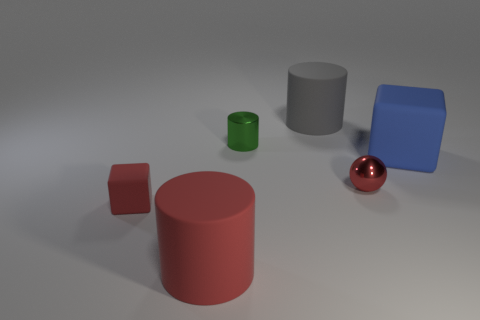There is a tiny block that is the same color as the tiny metallic ball; what is its material?
Offer a terse response. Rubber. How many things are small objects on the left side of the red cylinder or large things?
Offer a very short reply. 4. There is a large cylinder right of the big red rubber object; how many big matte cylinders are left of it?
Offer a terse response. 1. Is the number of big gray objects that are right of the big blue matte block less than the number of small metallic objects that are behind the red shiny thing?
Give a very brief answer. Yes. There is a tiny shiny thing that is in front of the matte cube that is to the right of the big gray object; what shape is it?
Keep it short and to the point. Sphere. What number of other things are the same material as the blue cube?
Provide a short and direct response. 3. Are there more tiny red things than rubber objects?
Your answer should be compact. No. There is a red object behind the rubber block to the left of the matte cylinder that is in front of the small red matte block; what size is it?
Provide a short and direct response. Small. There is a red rubber cube; is it the same size as the metallic thing on the left side of the gray cylinder?
Your response must be concise. Yes. Is the number of large matte objects that are in front of the tiny matte thing less than the number of blue matte cubes?
Offer a very short reply. No. 